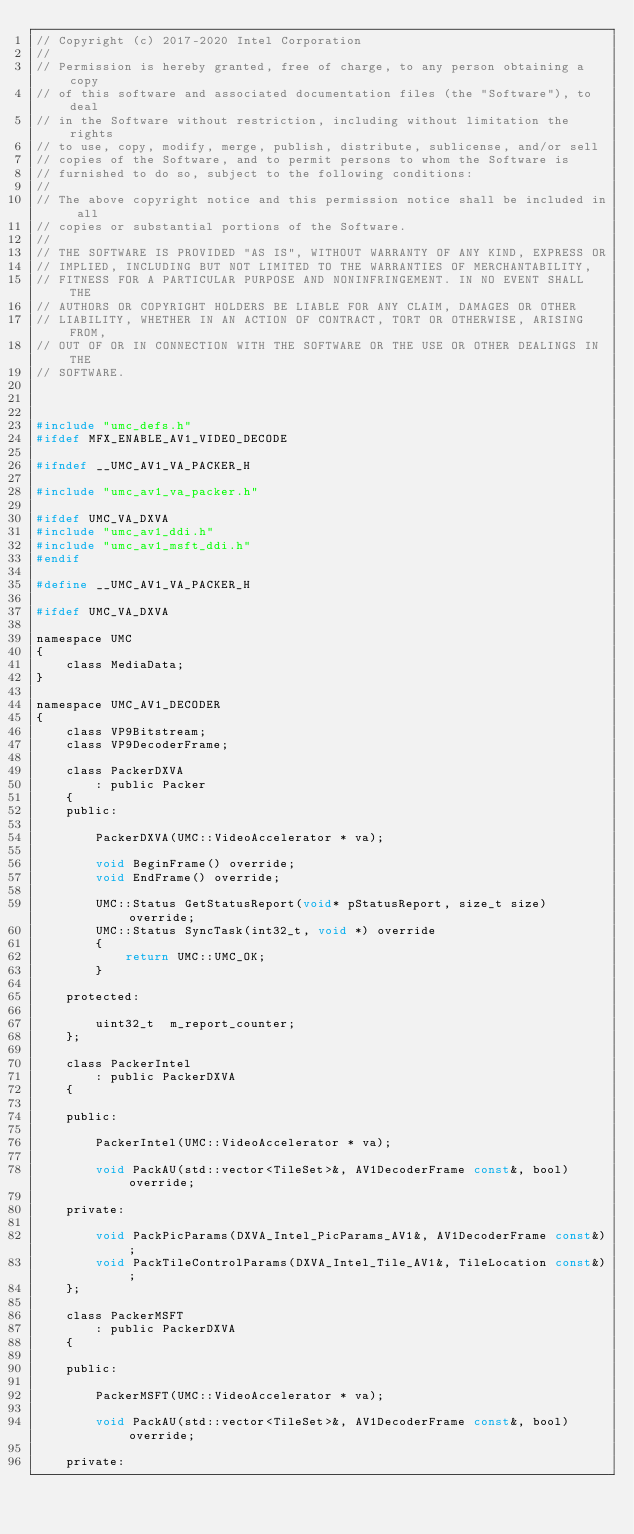Convert code to text. <code><loc_0><loc_0><loc_500><loc_500><_C_>// Copyright (c) 2017-2020 Intel Corporation
//
// Permission is hereby granted, free of charge, to any person obtaining a copy
// of this software and associated documentation files (the "Software"), to deal
// in the Software without restriction, including without limitation the rights
// to use, copy, modify, merge, publish, distribute, sublicense, and/or sell
// copies of the Software, and to permit persons to whom the Software is
// furnished to do so, subject to the following conditions:
//
// The above copyright notice and this permission notice shall be included in all
// copies or substantial portions of the Software.
//
// THE SOFTWARE IS PROVIDED "AS IS", WITHOUT WARRANTY OF ANY KIND, EXPRESS OR
// IMPLIED, INCLUDING BUT NOT LIMITED TO THE WARRANTIES OF MERCHANTABILITY,
// FITNESS FOR A PARTICULAR PURPOSE AND NONINFRINGEMENT. IN NO EVENT SHALL THE
// AUTHORS OR COPYRIGHT HOLDERS BE LIABLE FOR ANY CLAIM, DAMAGES OR OTHER
// LIABILITY, WHETHER IN AN ACTION OF CONTRACT, TORT OR OTHERWISE, ARISING FROM,
// OUT OF OR IN CONNECTION WITH THE SOFTWARE OR THE USE OR OTHER DEALINGS IN THE
// SOFTWARE.



#include "umc_defs.h"
#ifdef MFX_ENABLE_AV1_VIDEO_DECODE

#ifndef __UMC_AV1_VA_PACKER_H

#include "umc_av1_va_packer.h"

#ifdef UMC_VA_DXVA
#include "umc_av1_ddi.h"
#include "umc_av1_msft_ddi.h"
#endif

#define __UMC_AV1_VA_PACKER_H

#ifdef UMC_VA_DXVA

namespace UMC
{
    class MediaData;
}

namespace UMC_AV1_DECODER
{
    class VP9Bitstream;
    class VP9DecoderFrame;

    class PackerDXVA
        : public Packer
    {
    public:

        PackerDXVA(UMC::VideoAccelerator * va);

        void BeginFrame() override;
        void EndFrame() override;

        UMC::Status GetStatusReport(void* pStatusReport, size_t size) override;
        UMC::Status SyncTask(int32_t, void *) override
        {
            return UMC::UMC_OK;
        }

    protected:

        uint32_t  m_report_counter;
    };

    class PackerIntel
        : public PackerDXVA
    {

    public:

        PackerIntel(UMC::VideoAccelerator * va);

        void PackAU(std::vector<TileSet>&, AV1DecoderFrame const&, bool) override;

    private:

        void PackPicParams(DXVA_Intel_PicParams_AV1&, AV1DecoderFrame const&);
        void PackTileControlParams(DXVA_Intel_Tile_AV1&, TileLocation const&);
    };

    class PackerMSFT
        : public PackerDXVA
    {

    public:

        PackerMSFT(UMC::VideoAccelerator * va);

        void PackAU(std::vector<TileSet>&, AV1DecoderFrame const&, bool) override;

    private:
</code> 